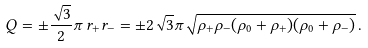<formula> <loc_0><loc_0><loc_500><loc_500>Q = \pm \frac { \sqrt { 3 } } { 2 } \pi \, r _ { + } r _ { - } = \pm 2 \sqrt { 3 } \pi \sqrt { \rho _ { + } \rho _ { - } ( \rho _ { 0 } + \rho _ { + } ) ( \rho _ { 0 } + \rho _ { - } ) } \, .</formula> 